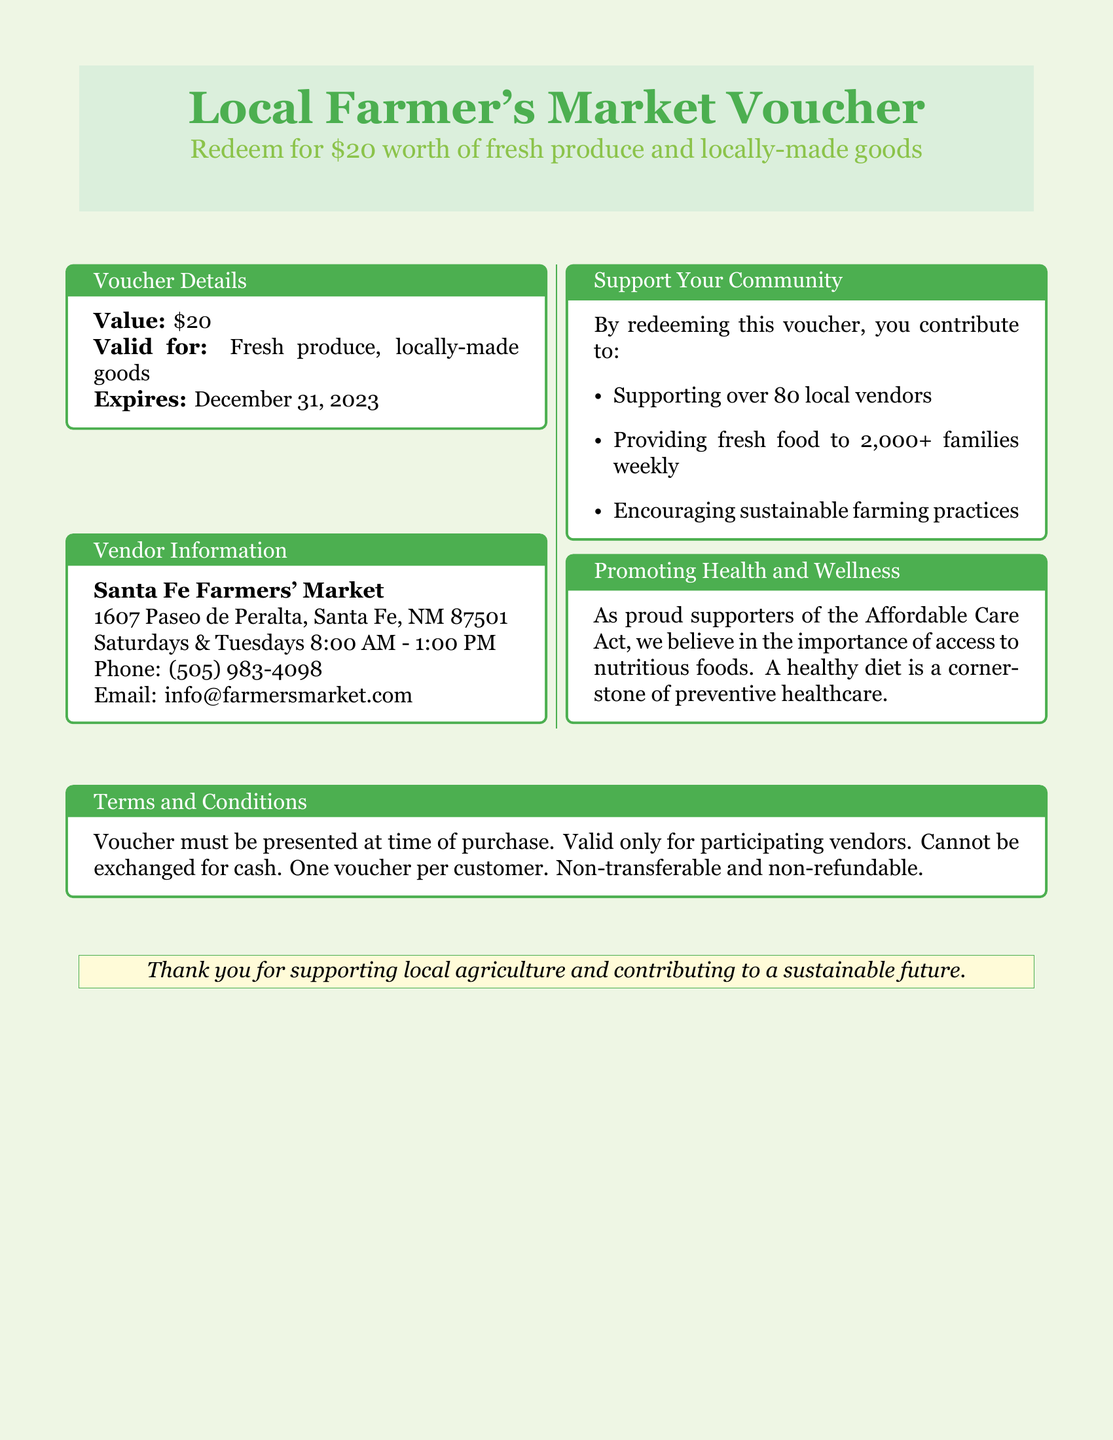What is the value of the voucher? The value of the voucher is stated in the document, which is $20.
Answer: $20 Where can the voucher be redeemed? The document specifies the location where the voucher can be redeemed, which is Santa Fe Farmers' Market.
Answer: Santa Fe Farmers' Market What is the expiration date of the voucher? The expiration date is mentioned in the document, which is December 31, 2023.
Answer: December 31, 2023 How many local vendors are supported by redeeming this voucher? The document states that redeeming the voucher supports over 80 local vendors.
Answer: over 80 What are the operating days for the market? The document lists the operating days for the market as Saturdays and Tuesdays.
Answer: Saturdays and Tuesdays What items can the voucher be used for? The document indicates that the voucher can be used for fresh produce and locally-made goods.
Answer: fresh produce and locally-made goods What is the main belief expressed in relation to the Affordable Care Act? The document expresses the belief that access to nutritious foods is important for preventive healthcare.
Answer: access to nutritious foods What happens if the voucher is not used? The document specifies conditions that include non-transferability and that it cannot be exchanged for cash.
Answer: cannot be exchanged for cash 